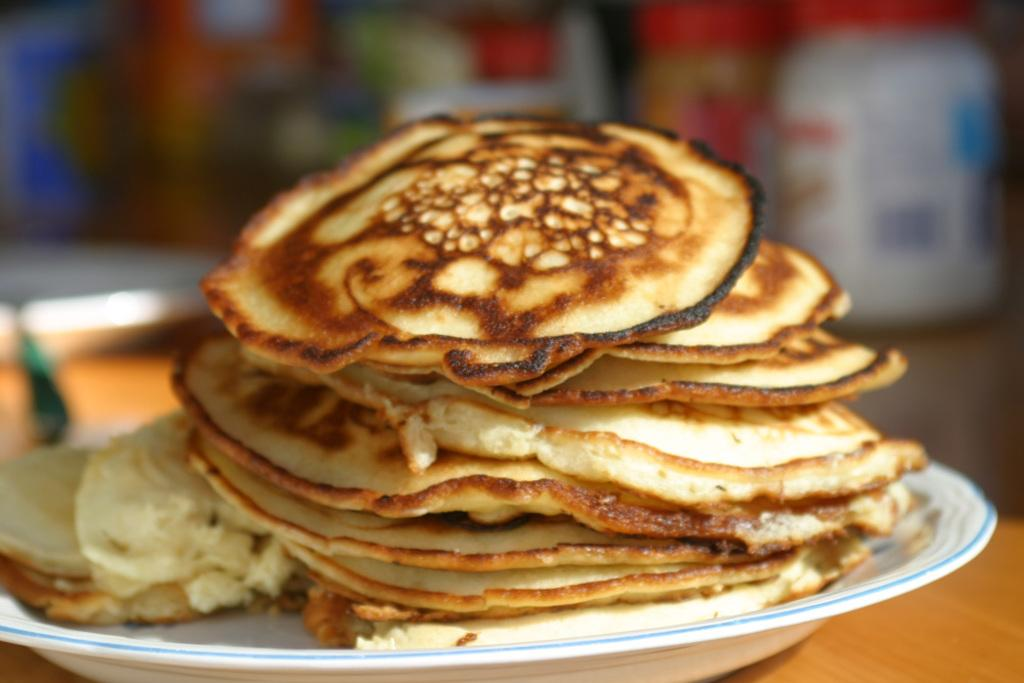What is the main subject in the foreground of the image? There are pancakes on a platter in the foreground of the image. What type of surface is the platter with pancakes resting on? The pancakes are on a wooden surface. Can you describe the background of the image? The background of the image is blurred. What type of snail can be seen crawling on the canvas in the image? There is no snail or canvas present in the image; it features pancakes on a wooden surface in the foreground and a blurred background. 